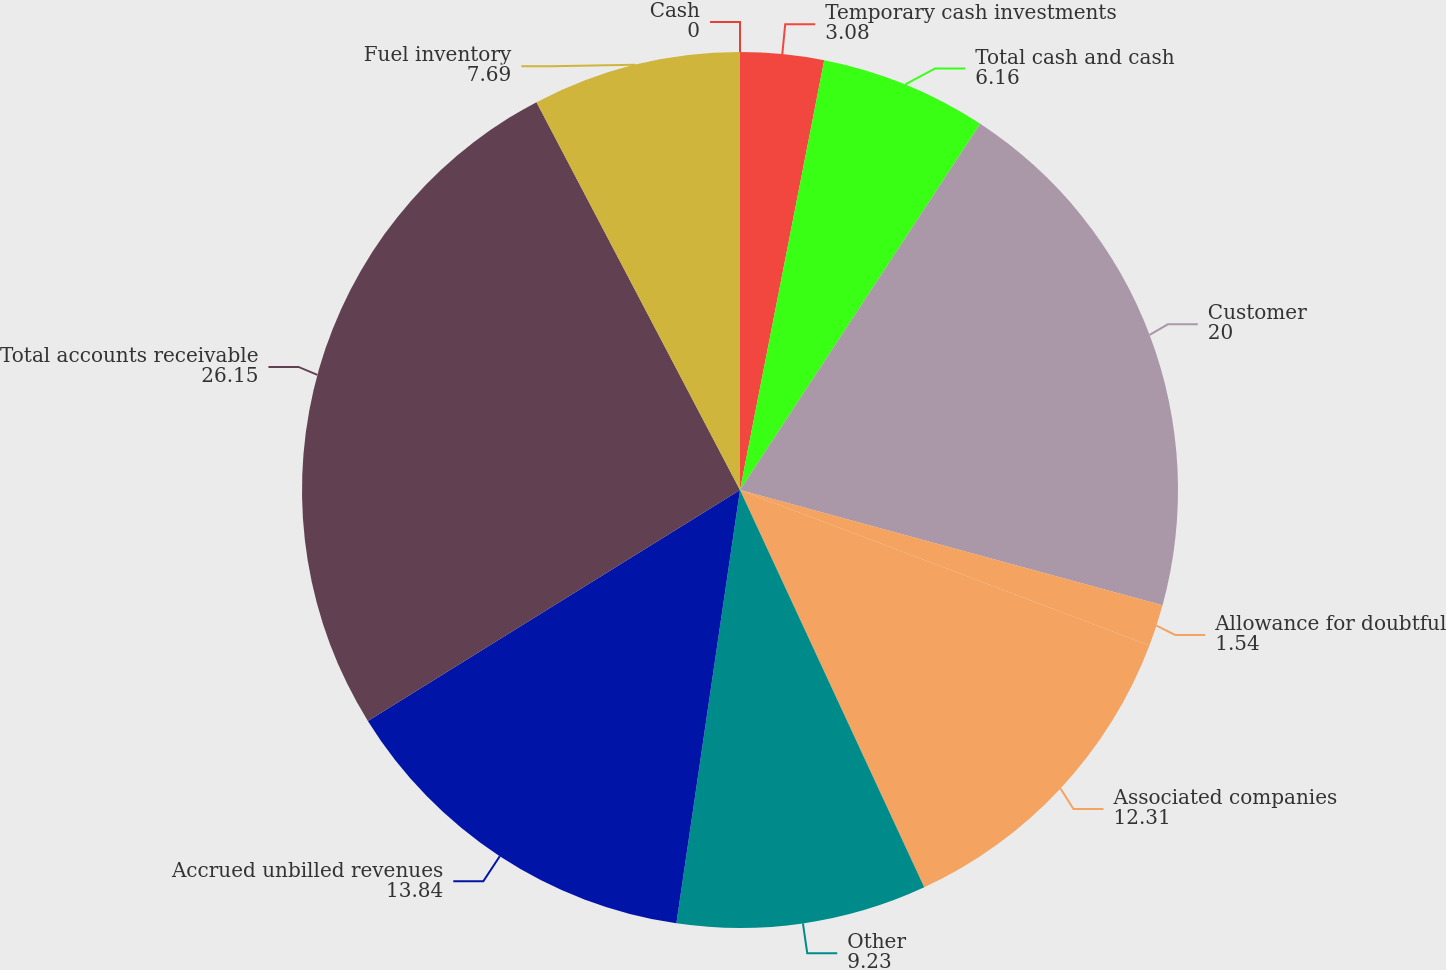Convert chart. <chart><loc_0><loc_0><loc_500><loc_500><pie_chart><fcel>Cash<fcel>Temporary cash investments<fcel>Total cash and cash<fcel>Customer<fcel>Allowance for doubtful<fcel>Associated companies<fcel>Other<fcel>Accrued unbilled revenues<fcel>Total accounts receivable<fcel>Fuel inventory<nl><fcel>0.0%<fcel>3.08%<fcel>6.16%<fcel>20.0%<fcel>1.54%<fcel>12.31%<fcel>9.23%<fcel>13.84%<fcel>26.15%<fcel>7.69%<nl></chart> 